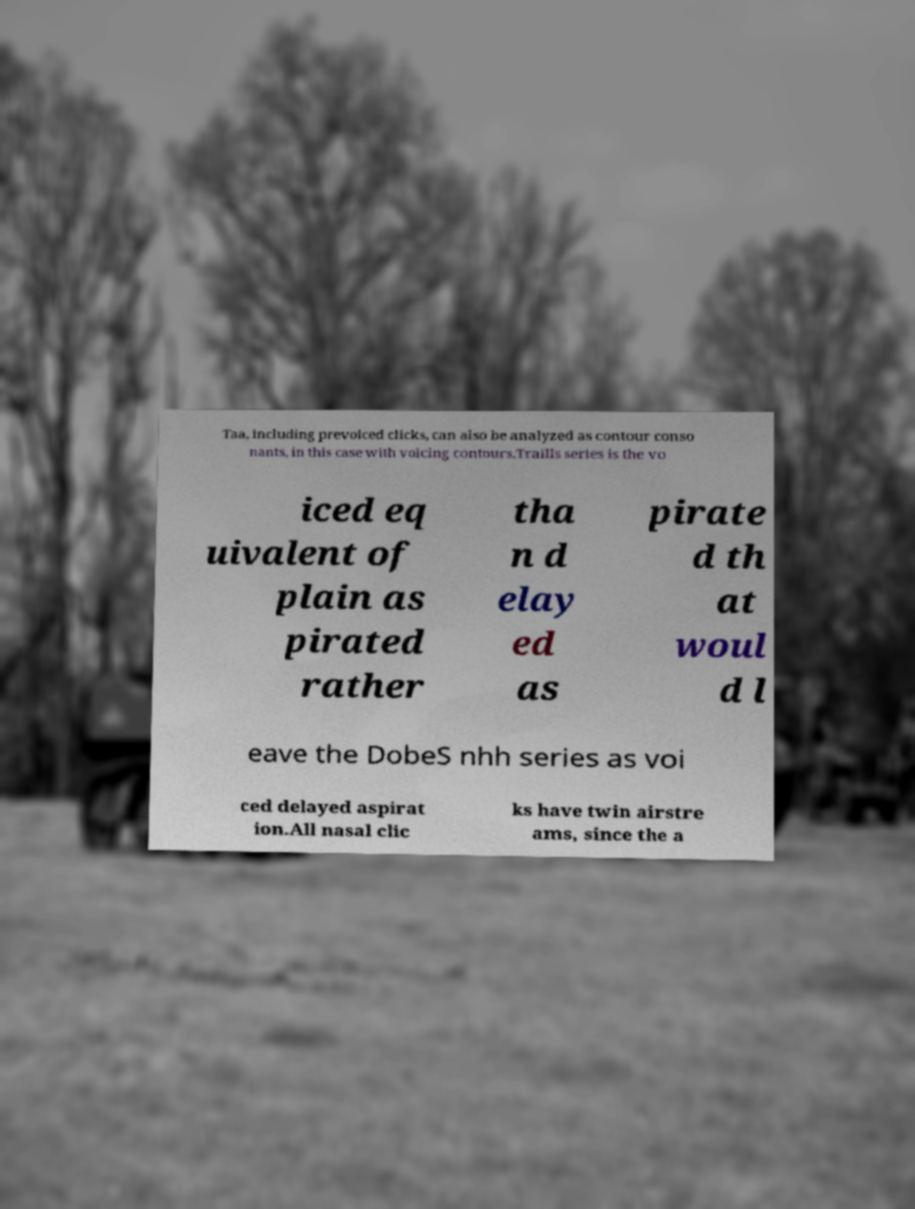There's text embedded in this image that I need extracted. Can you transcribe it verbatim? Taa, including prevoiced clicks, can also be analyzed as contour conso nants, in this case with voicing contours.Traills series is the vo iced eq uivalent of plain as pirated rather tha n d elay ed as pirate d th at woul d l eave the DobeS nhh series as voi ced delayed aspirat ion.All nasal clic ks have twin airstre ams, since the a 